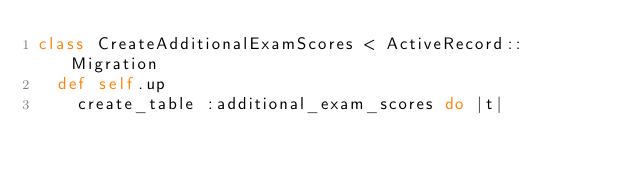Convert code to text. <code><loc_0><loc_0><loc_500><loc_500><_Ruby_>class CreateAdditionalExamScores < ActiveRecord::Migration
  def self.up
    create_table :additional_exam_scores do |t|</code> 